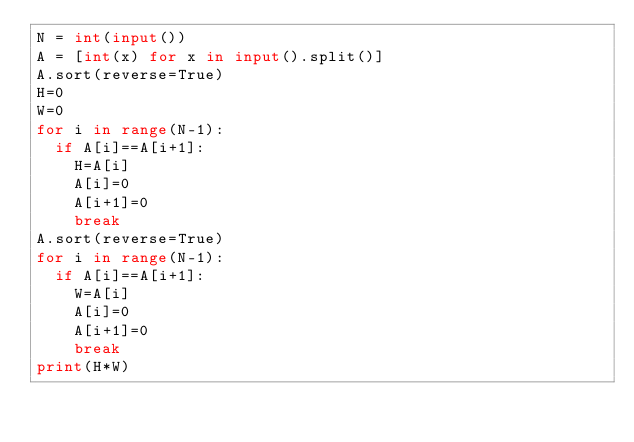<code> <loc_0><loc_0><loc_500><loc_500><_Python_>N = int(input())
A = [int(x) for x in input().split()]
A.sort(reverse=True)
H=0
W=0
for i in range(N-1):
  if A[i]==A[i+1]:
    H=A[i]
    A[i]=0
    A[i+1]=0
    break
A.sort(reverse=True)
for i in range(N-1):
  if A[i]==A[i+1]:
    W=A[i]
    A[i]=0
    A[i+1]=0
    break
print(H*W)</code> 